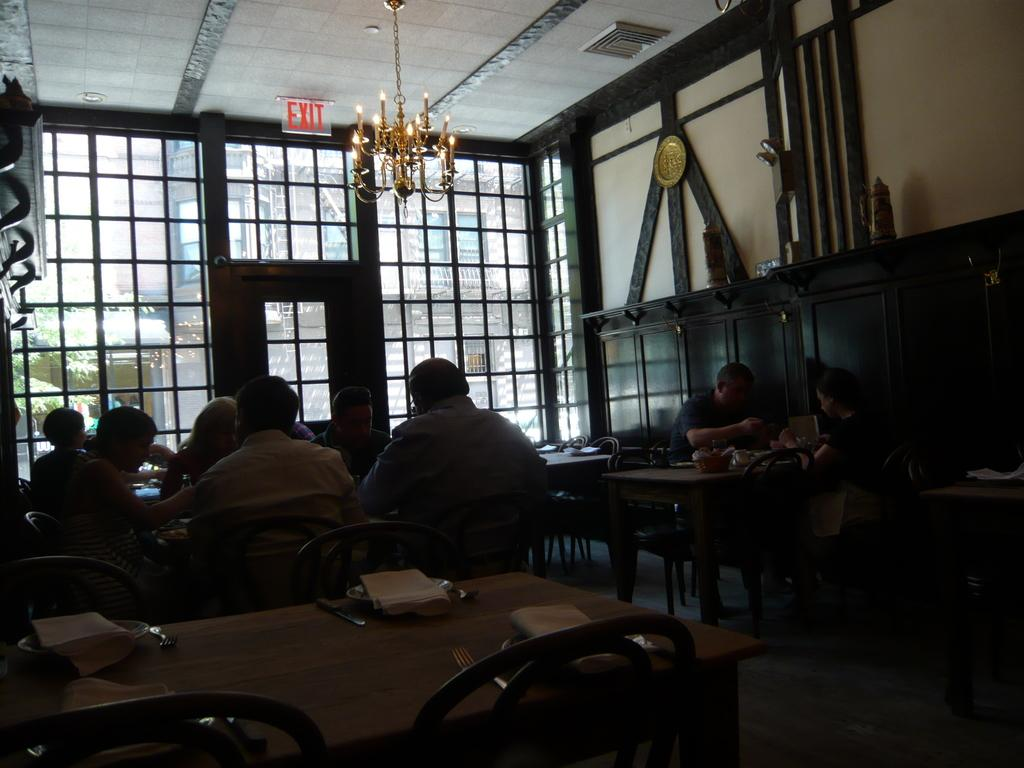How many people are in the image? There is a group of people in the image, but the exact number is not specified. What are the people doing in the image? The people are sitting in front of a table. What is on the table in the image? There is a plate, tissue, and spoons on the table. What can be seen in the background of the image? There are lights visible in the image, and there is an exit board. What invention is being demonstrated by the people in the image? There is no invention being demonstrated in the image; the people are simply sitting at a table. 